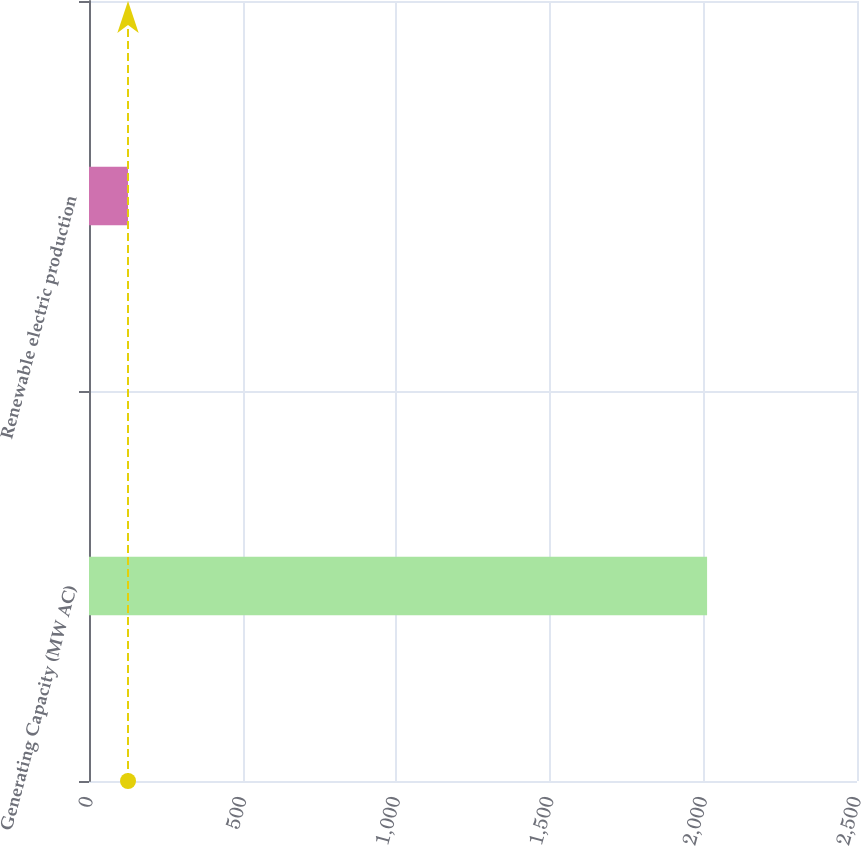Convert chart to OTSL. <chart><loc_0><loc_0><loc_500><loc_500><bar_chart><fcel>Generating Capacity (MW AC)<fcel>Renewable electric production<nl><fcel>2012<fcel>127<nl></chart> 